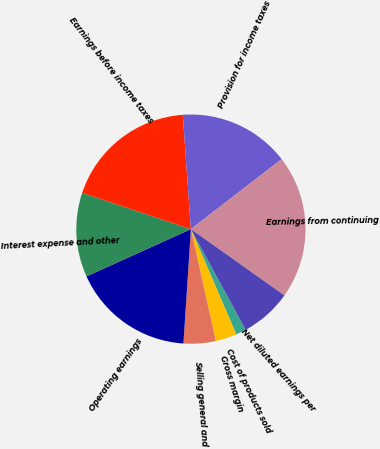Convert chart to OTSL. <chart><loc_0><loc_0><loc_500><loc_500><pie_chart><fcel>Cost of products sold<fcel>Gross margin<fcel>Selling general and<fcel>Operating earnings<fcel>Interest expense and other<fcel>Earnings before income taxes<fcel>Provision for income taxes<fcel>Earnings from continuing<fcel>Net diluted earnings per<nl><fcel>1.45%<fcel>2.99%<fcel>4.53%<fcel>17.2%<fcel>11.89%<fcel>18.74%<fcel>15.67%<fcel>20.28%<fcel>7.25%<nl></chart> 